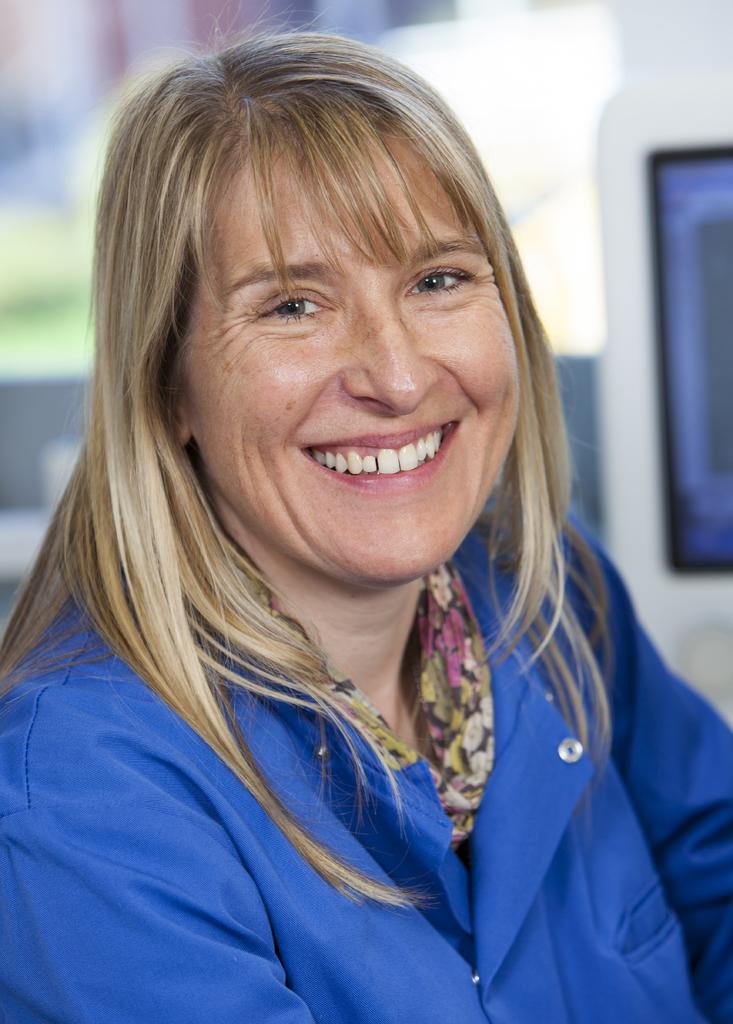What is the main subject of the image? The main subject of the image is a lady. What is the lady wearing in the image? The lady is wearing a blue dress in the image. What is the color of the lady's hair? The lady has brown hair in the image. What is the lady's facial expression in the image? The lady is smiling in the image. What word is being processed by the lady in the image? There is no indication in the image that the lady is processing any words. 